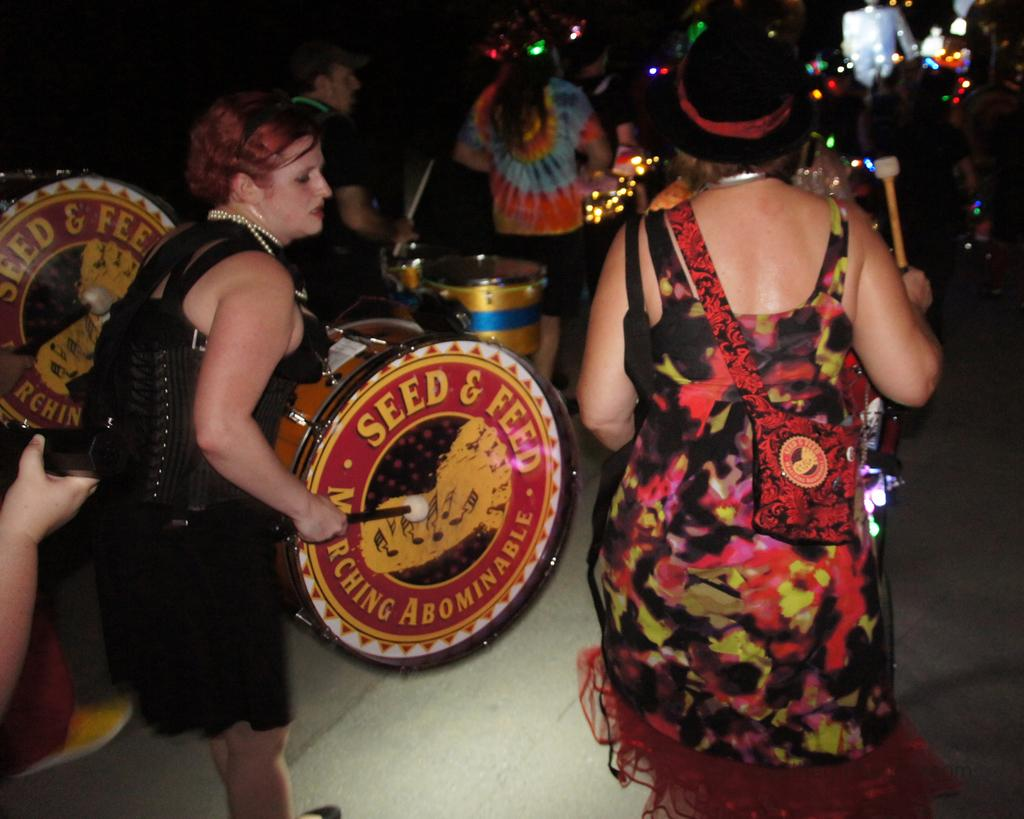Who or what is present in the image? There are people in the image. What are the people doing in the image? The people are standing and playing drums. Can you describe the background of the image? The background of the image is dark. Are there any kittens playing in the stream in the image? There are no kittens or streams present in the image; it features people playing drums with a dark background. 